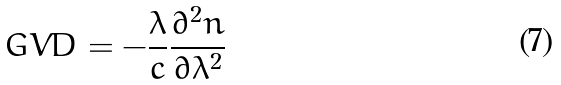Convert formula to latex. <formula><loc_0><loc_0><loc_500><loc_500>G V D = - \frac { \lambda } { c } \frac { \partial ^ { 2 } n } { \partial \lambda ^ { 2 } }</formula> 